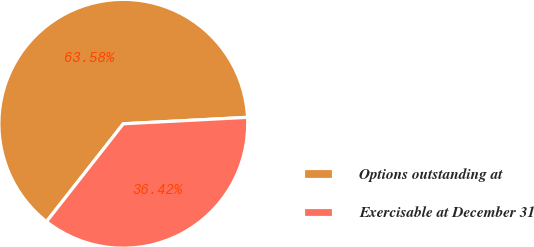Convert chart to OTSL. <chart><loc_0><loc_0><loc_500><loc_500><pie_chart><fcel>Options outstanding at<fcel>Exercisable at December 31<nl><fcel>63.58%<fcel>36.42%<nl></chart> 